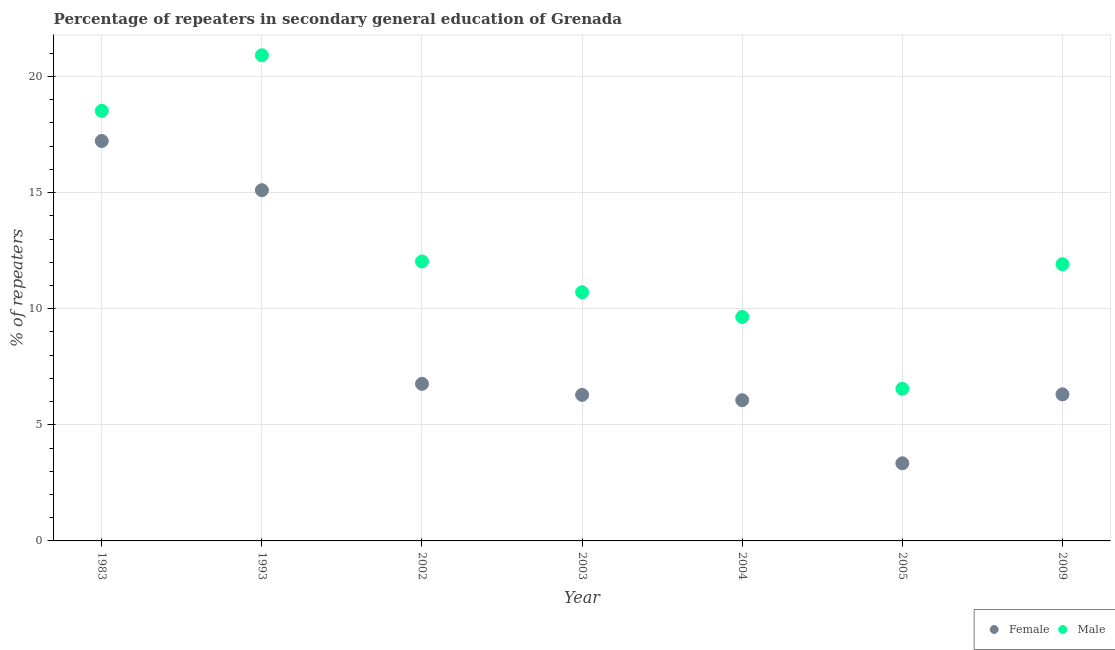Is the number of dotlines equal to the number of legend labels?
Provide a succinct answer. Yes. What is the percentage of female repeaters in 2002?
Offer a very short reply. 6.76. Across all years, what is the maximum percentage of female repeaters?
Your response must be concise. 17.22. Across all years, what is the minimum percentage of female repeaters?
Provide a short and direct response. 3.34. In which year was the percentage of female repeaters minimum?
Your response must be concise. 2005. What is the total percentage of female repeaters in the graph?
Your answer should be very brief. 61.09. What is the difference between the percentage of female repeaters in 1993 and that in 2002?
Make the answer very short. 8.34. What is the difference between the percentage of male repeaters in 1983 and the percentage of female repeaters in 2002?
Ensure brevity in your answer.  11.76. What is the average percentage of male repeaters per year?
Offer a very short reply. 12.9. In the year 2003, what is the difference between the percentage of female repeaters and percentage of male repeaters?
Offer a terse response. -4.42. What is the ratio of the percentage of male repeaters in 1983 to that in 2002?
Your answer should be very brief. 1.54. Is the percentage of male repeaters in 1983 less than that in 2002?
Give a very brief answer. No. What is the difference between the highest and the second highest percentage of female repeaters?
Give a very brief answer. 2.12. What is the difference between the highest and the lowest percentage of female repeaters?
Your response must be concise. 13.88. Does the percentage of female repeaters monotonically increase over the years?
Provide a short and direct response. No. Is the percentage of female repeaters strictly less than the percentage of male repeaters over the years?
Ensure brevity in your answer.  Yes. How many years are there in the graph?
Ensure brevity in your answer.  7. Are the values on the major ticks of Y-axis written in scientific E-notation?
Make the answer very short. No. Does the graph contain any zero values?
Offer a terse response. No. Where does the legend appear in the graph?
Give a very brief answer. Bottom right. How many legend labels are there?
Ensure brevity in your answer.  2. How are the legend labels stacked?
Offer a terse response. Horizontal. What is the title of the graph?
Provide a succinct answer. Percentage of repeaters in secondary general education of Grenada. Does "UN agencies" appear as one of the legend labels in the graph?
Provide a succinct answer. No. What is the label or title of the Y-axis?
Offer a very short reply. % of repeaters. What is the % of repeaters in Female in 1983?
Provide a short and direct response. 17.22. What is the % of repeaters of Male in 1983?
Your answer should be compact. 18.52. What is the % of repeaters in Female in 1993?
Make the answer very short. 15.1. What is the % of repeaters in Male in 1993?
Your answer should be very brief. 20.91. What is the % of repeaters in Female in 2002?
Ensure brevity in your answer.  6.76. What is the % of repeaters in Male in 2002?
Your response must be concise. 12.04. What is the % of repeaters in Female in 2003?
Give a very brief answer. 6.29. What is the % of repeaters in Male in 2003?
Your response must be concise. 10.71. What is the % of repeaters of Female in 2004?
Make the answer very short. 6.06. What is the % of repeaters of Male in 2004?
Your response must be concise. 9.64. What is the % of repeaters in Female in 2005?
Give a very brief answer. 3.34. What is the % of repeaters of Male in 2005?
Your response must be concise. 6.55. What is the % of repeaters of Female in 2009?
Ensure brevity in your answer.  6.31. What is the % of repeaters in Male in 2009?
Your answer should be very brief. 11.92. Across all years, what is the maximum % of repeaters in Female?
Your response must be concise. 17.22. Across all years, what is the maximum % of repeaters in Male?
Ensure brevity in your answer.  20.91. Across all years, what is the minimum % of repeaters in Female?
Offer a very short reply. 3.34. Across all years, what is the minimum % of repeaters of Male?
Make the answer very short. 6.55. What is the total % of repeaters of Female in the graph?
Offer a very short reply. 61.09. What is the total % of repeaters of Male in the graph?
Your answer should be compact. 90.3. What is the difference between the % of repeaters in Female in 1983 and that in 1993?
Your answer should be very brief. 2.12. What is the difference between the % of repeaters of Male in 1983 and that in 1993?
Provide a short and direct response. -2.39. What is the difference between the % of repeaters in Female in 1983 and that in 2002?
Make the answer very short. 10.46. What is the difference between the % of repeaters of Male in 1983 and that in 2002?
Provide a succinct answer. 6.49. What is the difference between the % of repeaters in Female in 1983 and that in 2003?
Your response must be concise. 10.93. What is the difference between the % of repeaters of Male in 1983 and that in 2003?
Your answer should be very brief. 7.81. What is the difference between the % of repeaters in Female in 1983 and that in 2004?
Offer a very short reply. 11.16. What is the difference between the % of repeaters in Male in 1983 and that in 2004?
Offer a terse response. 8.88. What is the difference between the % of repeaters of Female in 1983 and that in 2005?
Your answer should be very brief. 13.88. What is the difference between the % of repeaters of Male in 1983 and that in 2005?
Provide a short and direct response. 11.97. What is the difference between the % of repeaters in Female in 1983 and that in 2009?
Offer a terse response. 10.91. What is the difference between the % of repeaters in Male in 1983 and that in 2009?
Keep it short and to the point. 6.6. What is the difference between the % of repeaters of Female in 1993 and that in 2002?
Your response must be concise. 8.34. What is the difference between the % of repeaters of Male in 1993 and that in 2002?
Your answer should be compact. 8.88. What is the difference between the % of repeaters of Female in 1993 and that in 2003?
Make the answer very short. 8.81. What is the difference between the % of repeaters in Male in 1993 and that in 2003?
Give a very brief answer. 10.2. What is the difference between the % of repeaters of Female in 1993 and that in 2004?
Ensure brevity in your answer.  9.04. What is the difference between the % of repeaters of Male in 1993 and that in 2004?
Your answer should be compact. 11.27. What is the difference between the % of repeaters of Female in 1993 and that in 2005?
Make the answer very short. 11.76. What is the difference between the % of repeaters of Male in 1993 and that in 2005?
Provide a succinct answer. 14.36. What is the difference between the % of repeaters in Female in 1993 and that in 2009?
Ensure brevity in your answer.  8.79. What is the difference between the % of repeaters in Male in 1993 and that in 2009?
Keep it short and to the point. 9. What is the difference between the % of repeaters in Female in 2002 and that in 2003?
Your answer should be compact. 0.47. What is the difference between the % of repeaters of Male in 2002 and that in 2003?
Your response must be concise. 1.32. What is the difference between the % of repeaters in Female in 2002 and that in 2004?
Your answer should be compact. 0.7. What is the difference between the % of repeaters of Male in 2002 and that in 2004?
Provide a short and direct response. 2.39. What is the difference between the % of repeaters of Female in 2002 and that in 2005?
Your answer should be compact. 3.42. What is the difference between the % of repeaters in Male in 2002 and that in 2005?
Keep it short and to the point. 5.48. What is the difference between the % of repeaters of Female in 2002 and that in 2009?
Provide a succinct answer. 0.45. What is the difference between the % of repeaters of Male in 2002 and that in 2009?
Provide a short and direct response. 0.12. What is the difference between the % of repeaters of Female in 2003 and that in 2004?
Your answer should be very brief. 0.23. What is the difference between the % of repeaters in Male in 2003 and that in 2004?
Offer a very short reply. 1.07. What is the difference between the % of repeaters of Female in 2003 and that in 2005?
Ensure brevity in your answer.  2.95. What is the difference between the % of repeaters of Male in 2003 and that in 2005?
Your answer should be compact. 4.16. What is the difference between the % of repeaters of Female in 2003 and that in 2009?
Give a very brief answer. -0.02. What is the difference between the % of repeaters in Male in 2003 and that in 2009?
Offer a terse response. -1.21. What is the difference between the % of repeaters in Female in 2004 and that in 2005?
Keep it short and to the point. 2.72. What is the difference between the % of repeaters in Male in 2004 and that in 2005?
Keep it short and to the point. 3.09. What is the difference between the % of repeaters in Female in 2004 and that in 2009?
Keep it short and to the point. -0.25. What is the difference between the % of repeaters in Male in 2004 and that in 2009?
Your response must be concise. -2.28. What is the difference between the % of repeaters in Female in 2005 and that in 2009?
Your answer should be compact. -2.97. What is the difference between the % of repeaters of Male in 2005 and that in 2009?
Offer a very short reply. -5.37. What is the difference between the % of repeaters of Female in 1983 and the % of repeaters of Male in 1993?
Offer a very short reply. -3.69. What is the difference between the % of repeaters in Female in 1983 and the % of repeaters in Male in 2002?
Your answer should be compact. 5.19. What is the difference between the % of repeaters in Female in 1983 and the % of repeaters in Male in 2003?
Offer a very short reply. 6.51. What is the difference between the % of repeaters of Female in 1983 and the % of repeaters of Male in 2004?
Your answer should be compact. 7.58. What is the difference between the % of repeaters in Female in 1983 and the % of repeaters in Male in 2005?
Offer a terse response. 10.67. What is the difference between the % of repeaters of Female in 1983 and the % of repeaters of Male in 2009?
Your response must be concise. 5.3. What is the difference between the % of repeaters in Female in 1993 and the % of repeaters in Male in 2002?
Your answer should be very brief. 3.07. What is the difference between the % of repeaters in Female in 1993 and the % of repeaters in Male in 2003?
Offer a very short reply. 4.39. What is the difference between the % of repeaters of Female in 1993 and the % of repeaters of Male in 2004?
Offer a terse response. 5.46. What is the difference between the % of repeaters of Female in 1993 and the % of repeaters of Male in 2005?
Provide a short and direct response. 8.55. What is the difference between the % of repeaters in Female in 1993 and the % of repeaters in Male in 2009?
Ensure brevity in your answer.  3.18. What is the difference between the % of repeaters in Female in 2002 and the % of repeaters in Male in 2003?
Your response must be concise. -3.95. What is the difference between the % of repeaters in Female in 2002 and the % of repeaters in Male in 2004?
Ensure brevity in your answer.  -2.88. What is the difference between the % of repeaters of Female in 2002 and the % of repeaters of Male in 2005?
Provide a succinct answer. 0.21. What is the difference between the % of repeaters of Female in 2002 and the % of repeaters of Male in 2009?
Give a very brief answer. -5.15. What is the difference between the % of repeaters in Female in 2003 and the % of repeaters in Male in 2004?
Provide a short and direct response. -3.35. What is the difference between the % of repeaters in Female in 2003 and the % of repeaters in Male in 2005?
Keep it short and to the point. -0.26. What is the difference between the % of repeaters in Female in 2003 and the % of repeaters in Male in 2009?
Offer a terse response. -5.63. What is the difference between the % of repeaters of Female in 2004 and the % of repeaters of Male in 2005?
Your answer should be very brief. -0.49. What is the difference between the % of repeaters of Female in 2004 and the % of repeaters of Male in 2009?
Offer a very short reply. -5.86. What is the difference between the % of repeaters in Female in 2005 and the % of repeaters in Male in 2009?
Make the answer very short. -8.58. What is the average % of repeaters in Female per year?
Your answer should be very brief. 8.73. What is the average % of repeaters of Male per year?
Your response must be concise. 12.9. In the year 1983, what is the difference between the % of repeaters in Female and % of repeaters in Male?
Offer a terse response. -1.3. In the year 1993, what is the difference between the % of repeaters of Female and % of repeaters of Male?
Give a very brief answer. -5.81. In the year 2002, what is the difference between the % of repeaters in Female and % of repeaters in Male?
Offer a terse response. -5.27. In the year 2003, what is the difference between the % of repeaters in Female and % of repeaters in Male?
Keep it short and to the point. -4.42. In the year 2004, what is the difference between the % of repeaters of Female and % of repeaters of Male?
Offer a very short reply. -3.58. In the year 2005, what is the difference between the % of repeaters in Female and % of repeaters in Male?
Provide a short and direct response. -3.21. In the year 2009, what is the difference between the % of repeaters in Female and % of repeaters in Male?
Offer a very short reply. -5.61. What is the ratio of the % of repeaters of Female in 1983 to that in 1993?
Your response must be concise. 1.14. What is the ratio of the % of repeaters of Male in 1983 to that in 1993?
Make the answer very short. 0.89. What is the ratio of the % of repeaters of Female in 1983 to that in 2002?
Keep it short and to the point. 2.55. What is the ratio of the % of repeaters of Male in 1983 to that in 2002?
Give a very brief answer. 1.54. What is the ratio of the % of repeaters in Female in 1983 to that in 2003?
Ensure brevity in your answer.  2.74. What is the ratio of the % of repeaters in Male in 1983 to that in 2003?
Offer a terse response. 1.73. What is the ratio of the % of repeaters of Female in 1983 to that in 2004?
Ensure brevity in your answer.  2.84. What is the ratio of the % of repeaters of Male in 1983 to that in 2004?
Give a very brief answer. 1.92. What is the ratio of the % of repeaters of Female in 1983 to that in 2005?
Keep it short and to the point. 5.15. What is the ratio of the % of repeaters of Male in 1983 to that in 2005?
Keep it short and to the point. 2.83. What is the ratio of the % of repeaters in Female in 1983 to that in 2009?
Ensure brevity in your answer.  2.73. What is the ratio of the % of repeaters in Male in 1983 to that in 2009?
Offer a terse response. 1.55. What is the ratio of the % of repeaters in Female in 1993 to that in 2002?
Your answer should be compact. 2.23. What is the ratio of the % of repeaters of Male in 1993 to that in 2002?
Provide a short and direct response. 1.74. What is the ratio of the % of repeaters of Female in 1993 to that in 2003?
Offer a terse response. 2.4. What is the ratio of the % of repeaters in Male in 1993 to that in 2003?
Offer a terse response. 1.95. What is the ratio of the % of repeaters in Female in 1993 to that in 2004?
Provide a succinct answer. 2.49. What is the ratio of the % of repeaters of Male in 1993 to that in 2004?
Offer a very short reply. 2.17. What is the ratio of the % of repeaters in Female in 1993 to that in 2005?
Offer a terse response. 4.52. What is the ratio of the % of repeaters in Male in 1993 to that in 2005?
Offer a terse response. 3.19. What is the ratio of the % of repeaters of Female in 1993 to that in 2009?
Make the answer very short. 2.39. What is the ratio of the % of repeaters of Male in 1993 to that in 2009?
Offer a terse response. 1.75. What is the ratio of the % of repeaters in Female in 2002 to that in 2003?
Provide a short and direct response. 1.08. What is the ratio of the % of repeaters in Male in 2002 to that in 2003?
Make the answer very short. 1.12. What is the ratio of the % of repeaters in Female in 2002 to that in 2004?
Your answer should be very brief. 1.12. What is the ratio of the % of repeaters in Male in 2002 to that in 2004?
Provide a succinct answer. 1.25. What is the ratio of the % of repeaters in Female in 2002 to that in 2005?
Your response must be concise. 2.02. What is the ratio of the % of repeaters of Male in 2002 to that in 2005?
Ensure brevity in your answer.  1.84. What is the ratio of the % of repeaters in Female in 2002 to that in 2009?
Offer a very short reply. 1.07. What is the ratio of the % of repeaters in Male in 2002 to that in 2009?
Make the answer very short. 1.01. What is the ratio of the % of repeaters of Female in 2003 to that in 2004?
Your answer should be very brief. 1.04. What is the ratio of the % of repeaters of Male in 2003 to that in 2004?
Provide a short and direct response. 1.11. What is the ratio of the % of repeaters in Female in 2003 to that in 2005?
Provide a short and direct response. 1.88. What is the ratio of the % of repeaters in Male in 2003 to that in 2005?
Your response must be concise. 1.63. What is the ratio of the % of repeaters of Male in 2003 to that in 2009?
Your answer should be compact. 0.9. What is the ratio of the % of repeaters of Female in 2004 to that in 2005?
Provide a short and direct response. 1.81. What is the ratio of the % of repeaters of Male in 2004 to that in 2005?
Keep it short and to the point. 1.47. What is the ratio of the % of repeaters of Female in 2004 to that in 2009?
Your answer should be very brief. 0.96. What is the ratio of the % of repeaters in Male in 2004 to that in 2009?
Provide a short and direct response. 0.81. What is the ratio of the % of repeaters of Female in 2005 to that in 2009?
Provide a short and direct response. 0.53. What is the ratio of the % of repeaters of Male in 2005 to that in 2009?
Your answer should be very brief. 0.55. What is the difference between the highest and the second highest % of repeaters of Female?
Keep it short and to the point. 2.12. What is the difference between the highest and the second highest % of repeaters of Male?
Provide a succinct answer. 2.39. What is the difference between the highest and the lowest % of repeaters of Female?
Your answer should be very brief. 13.88. What is the difference between the highest and the lowest % of repeaters of Male?
Ensure brevity in your answer.  14.36. 